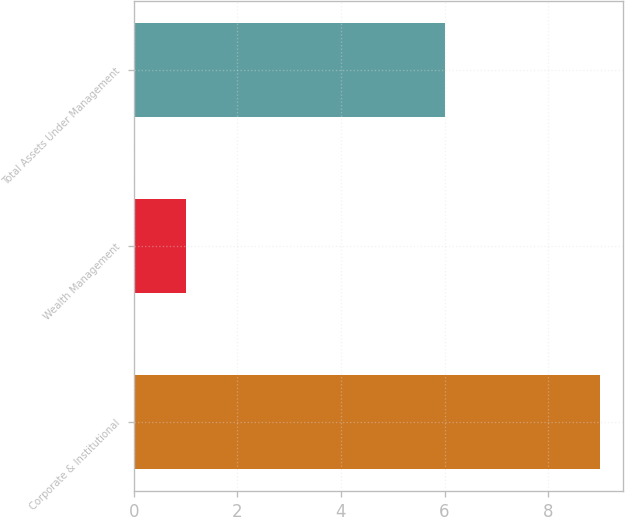Convert chart to OTSL. <chart><loc_0><loc_0><loc_500><loc_500><bar_chart><fcel>Corporate & Institutional<fcel>Wealth Management<fcel>Total Assets Under Management<nl><fcel>9<fcel>1<fcel>6<nl></chart> 